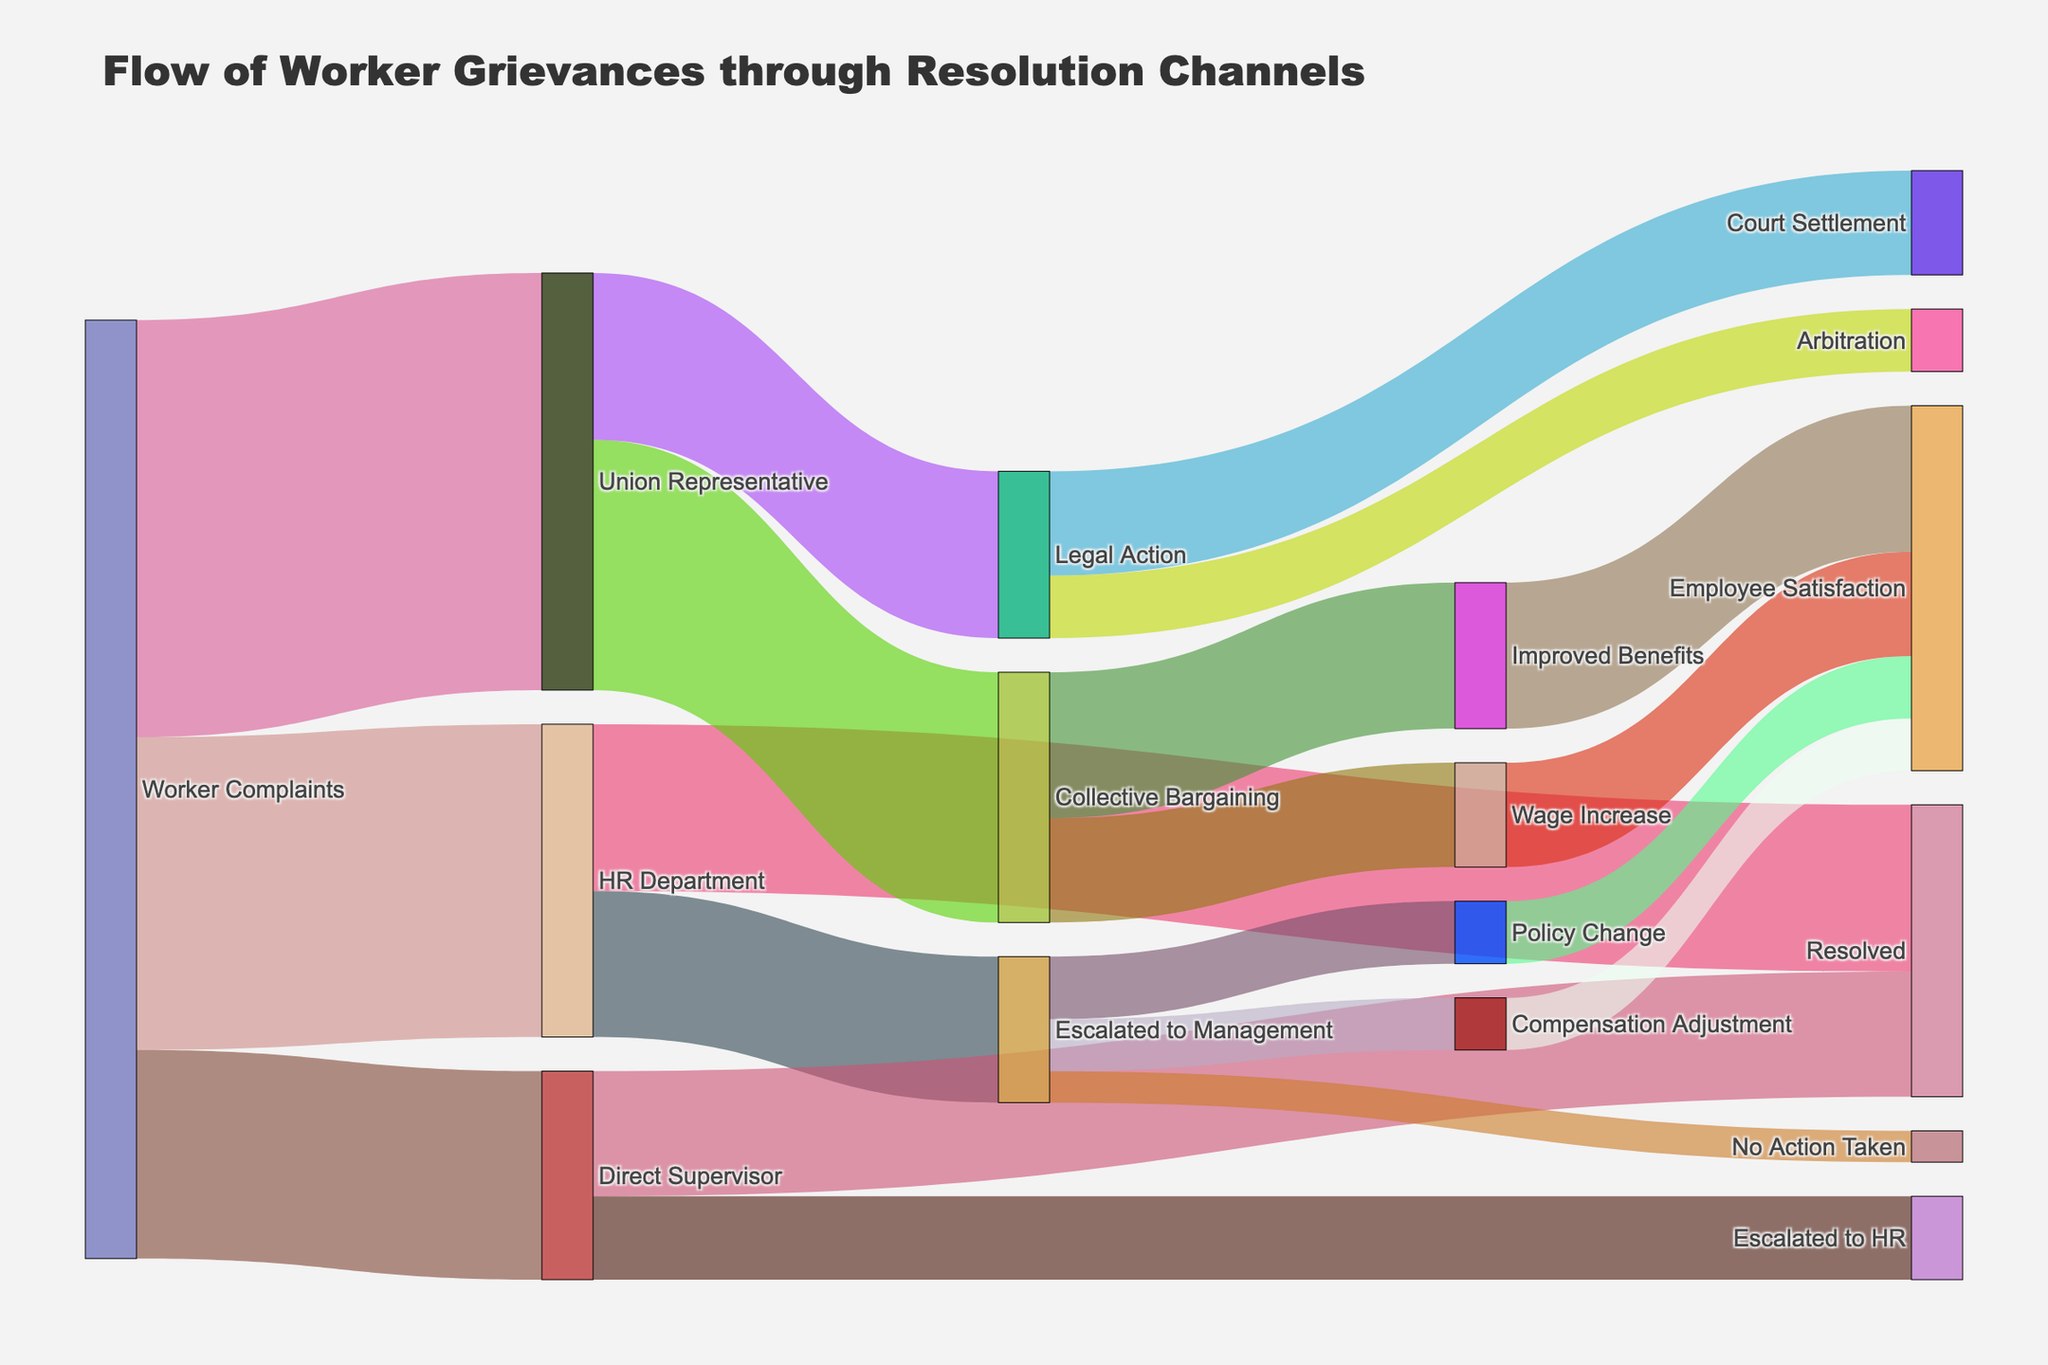How many worker complaints were initially filed? The Sankey diagram shows three primary flows from 'Worker Complaints' to 'HR Department', 'Union Representative', and 'Direct Supervisor', with values 150, 200, and 100 respectively. Summing these values gives the total number of initial complaints.
Answer: 450 What percentage of complaints were escalated to management by the HR Department? The diagram shows that the HR Department escalated 70 complaints to management out of the 150 complaints they received. To find the percentage, divide 70 by 150 and multiply by 100.
Answer: 46.67% Which resolution channel received the most complaints from workers? The Sankey diagram shows three pathways from 'Worker Complaints': 'HR Department' (150), 'Union Representative' (200), and 'Direct Supervisor' (100). The pathway to 'Union Representative' has the highest value.
Answer: Union Representative How many complaints were resolved by direct supervisors? The diagram shows a flow from 'Direct Supervisor' to 'Resolved' with a value of 60.
Answer: 60 What is the total number of complaints that resulted in employee satisfaction? The Sankey diagram shows several pathways leading to 'Employee Satisfaction': 'Policy Change' (30), 'Compensation Adjustment' (25), 'Wage Increase' (50), and 'Improved Benefits' (70). Summing these values gives the total.
Answer: 175 Which resolution channel led to the most improved benefits for employees? The Sankey diagram shows that 'Union Representative' leads to 'Collective Bargaining' with 120 complaints, and 'Collective Bargaining' leads to 'Improved Benefits' with 70 complaints. As 'Collective Bargaining' is a sub-pathway of 'Union Representative', it means the flow from 'Union Representative' contributes most to 'Improved Benefits'.
Answer: Union Representative What was the total number of complaints the HR Department managed (both resolved and escalated)? The diagram shows that the HR Department dealt with 150 complaints, resolving 80 and escalating 70. Summing these values gives us the total complaints managed by HR.
Answer: 150 What proportion of complaints sent to the union representative resulted in legal action? The diagram shows that the Union Representative managed 200 complaints, of which 80 were directed to 'Legal Action'. To find the proportion, divide 80 by 200.
Answer: 40% Did more complaints result in improved benefits or wage increase from collective bargaining? The Sankey diagram shows that from 'Collective Bargaining,' 70 resulted in 'Improved Benefits' and 50 in 'Wage Increase.' Comparatively, more complaints resulted in improved benefits.
Answer: Improved Benefits What was the fate of the complaints escalated to management that did not result in either policy changes or compensation adjustment? The diagram shows that management handled 70 complaints, of which 30 led to 'Policy Change' and 25 to 'Compensation Adjustment.' Subtracting these from 70 shows the complaints that resulted in 'No Action Taken.'
Answer: 15 